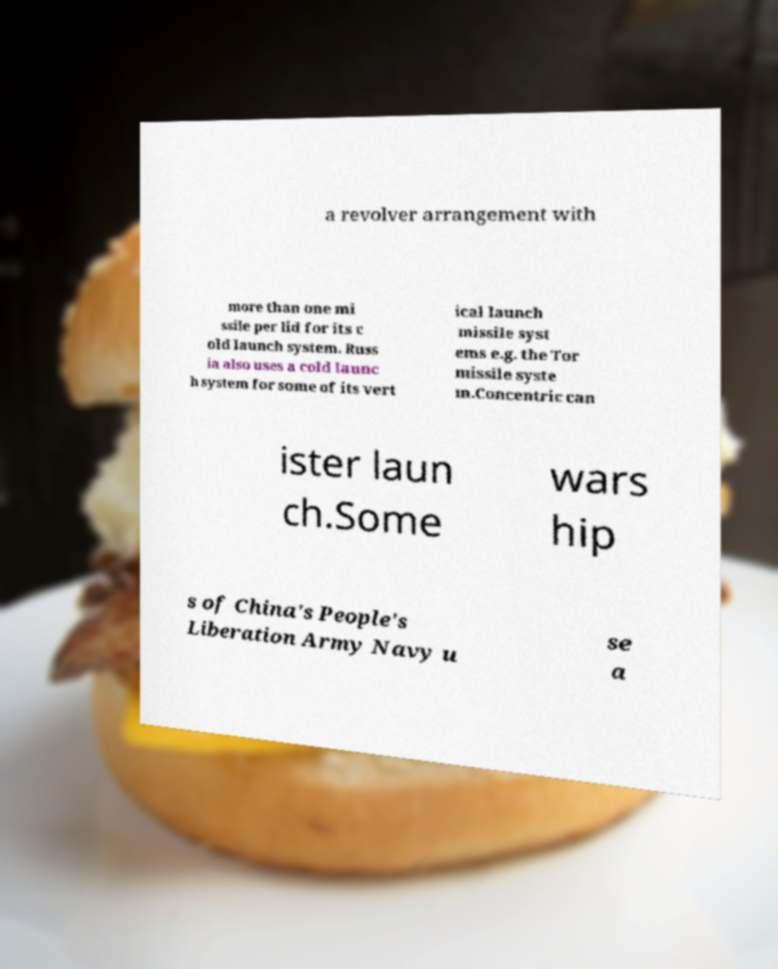Can you accurately transcribe the text from the provided image for me? a revolver arrangement with more than one mi ssile per lid for its c old launch system. Russ ia also uses a cold launc h system for some of its vert ical launch missile syst ems e.g. the Tor missile syste m.Concentric can ister laun ch.Some wars hip s of China's People's Liberation Army Navy u se a 